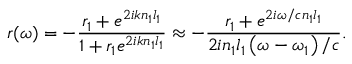<formula> <loc_0><loc_0><loc_500><loc_500>r ( \omega ) = - \frac { r _ { 1 } + e ^ { 2 i k n _ { 1 } l _ { 1 } } } { 1 + r _ { 1 } e ^ { 2 i k n _ { 1 } l _ { 1 } } } \approx - \frac { r _ { 1 } + e ^ { 2 i \omega / c n _ { 1 } l _ { 1 } } } { 2 i n _ { 1 } l _ { 1 } \left ( \omega - \omega _ { 1 } \right ) / c } .</formula> 